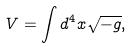<formula> <loc_0><loc_0><loc_500><loc_500>V = \int d ^ { 4 } x \sqrt { - g } ,</formula> 